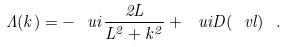Convert formula to latex. <formula><loc_0><loc_0><loc_500><loc_500>\Lambda ( k ) = - \ u i \frac { 2 L } { L ^ { 2 } + k ^ { 2 } } + \ u i D ( \ v l ) \ .</formula> 